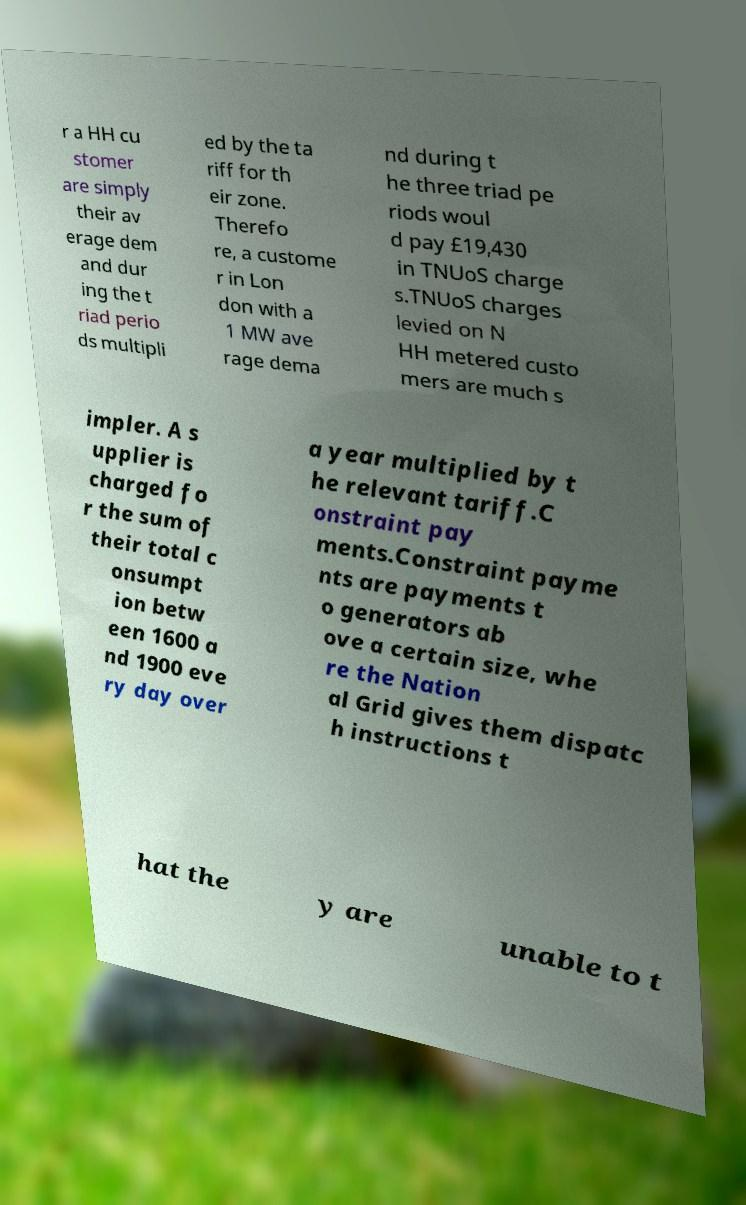Can you read and provide the text displayed in the image?This photo seems to have some interesting text. Can you extract and type it out for me? r a HH cu stomer are simply their av erage dem and dur ing the t riad perio ds multipli ed by the ta riff for th eir zone. Therefo re, a custome r in Lon don with a 1 MW ave rage dema nd during t he three triad pe riods woul d pay £19,430 in TNUoS charge s.TNUoS charges levied on N HH metered custo mers are much s impler. A s upplier is charged fo r the sum of their total c onsumpt ion betw een 1600 a nd 1900 eve ry day over a year multiplied by t he relevant tariff.C onstraint pay ments.Constraint payme nts are payments t o generators ab ove a certain size, whe re the Nation al Grid gives them dispatc h instructions t hat the y are unable to t 